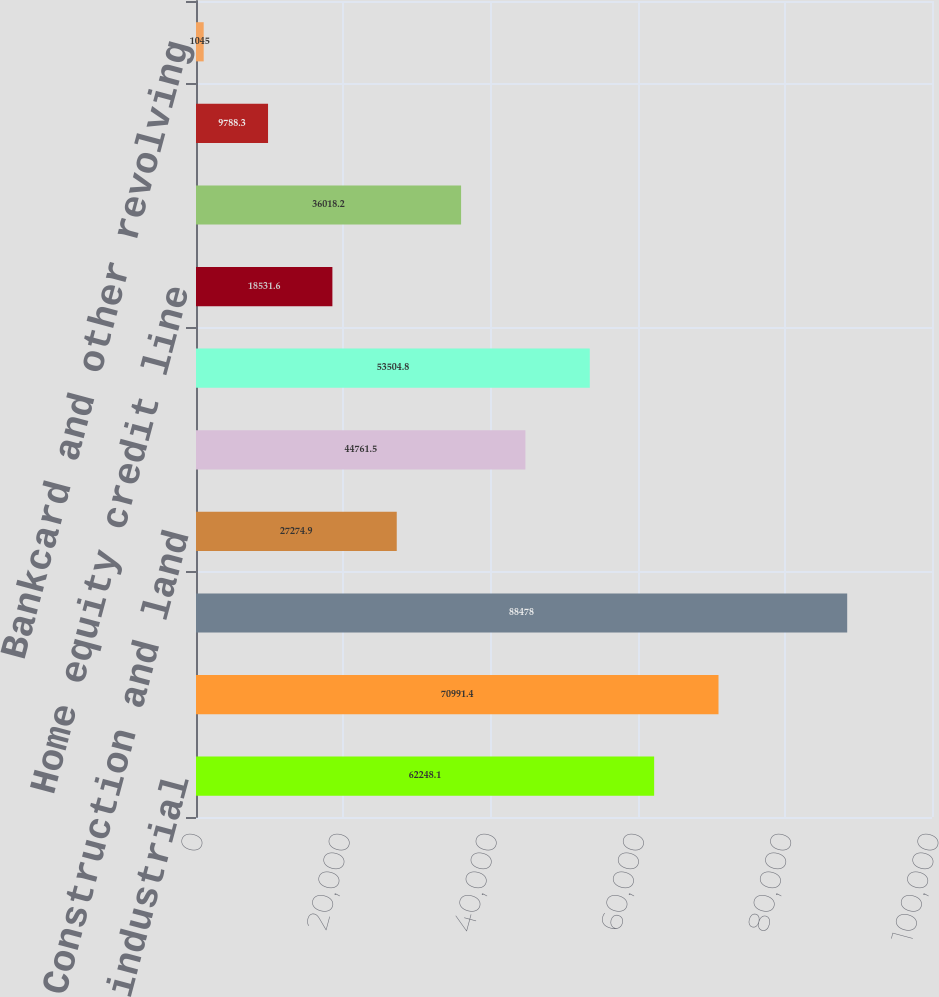<chart> <loc_0><loc_0><loc_500><loc_500><bar_chart><fcel>Commercial and industrial<fcel>Owner occupied<fcel>Total commercial<fcel>Construction and land<fcel>Term<fcel>Total commercial real estate<fcel>Home equity credit line<fcel>1-4 family residential<fcel>Construction and other<fcel>Bankcard and other revolving<nl><fcel>62248.1<fcel>70991.4<fcel>88478<fcel>27274.9<fcel>44761.5<fcel>53504.8<fcel>18531.6<fcel>36018.2<fcel>9788.3<fcel>1045<nl></chart> 